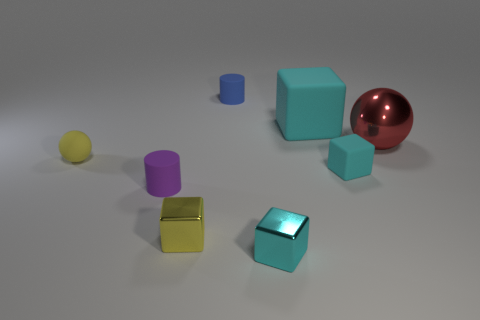What might be the material of the purple and yellow objects? The purple and yellow objects both have matte surfaces, suggesting they could be made of a non-reflective material such as plastic or a coated metal that diffuses light rather than reflecting it. 